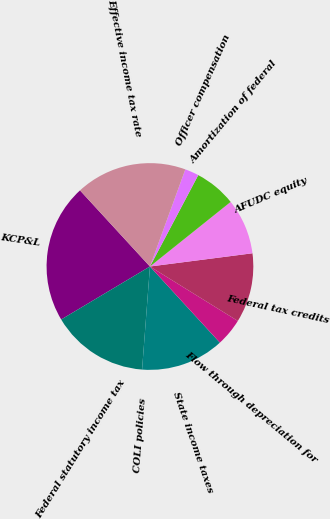<chart> <loc_0><loc_0><loc_500><loc_500><pie_chart><fcel>KCP&L<fcel>Federal statutory income tax<fcel>COLI policies<fcel>State income taxes<fcel>Flow through depreciation for<fcel>Federal tax credits<fcel>AFUDC equity<fcel>Amortization of federal<fcel>Officer compensation<fcel>Effective income tax rate<nl><fcel>21.74%<fcel>15.22%<fcel>0.0%<fcel>13.04%<fcel>4.35%<fcel>10.87%<fcel>8.7%<fcel>6.52%<fcel>2.18%<fcel>17.39%<nl></chart> 